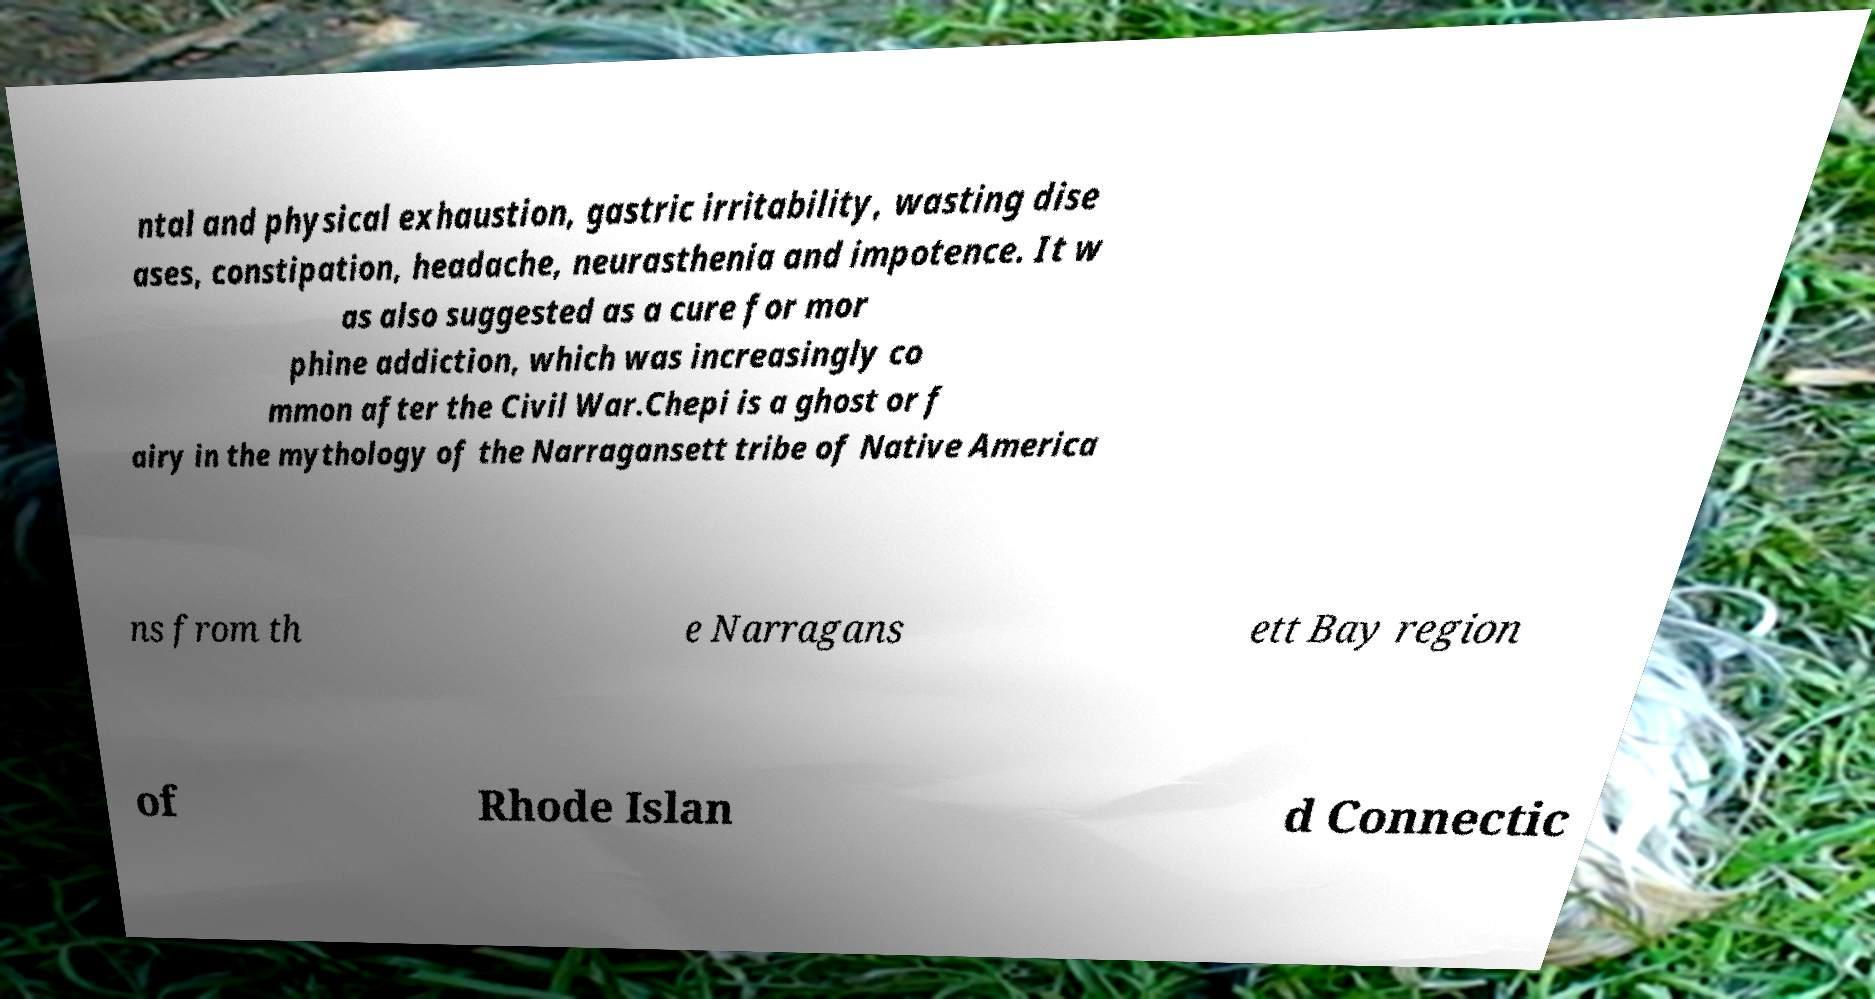Could you extract and type out the text from this image? ntal and physical exhaustion, gastric irritability, wasting dise ases, constipation, headache, neurasthenia and impotence. It w as also suggested as a cure for mor phine addiction, which was increasingly co mmon after the Civil War.Chepi is a ghost or f airy in the mythology of the Narragansett tribe of Native America ns from th e Narragans ett Bay region of Rhode Islan d Connectic 